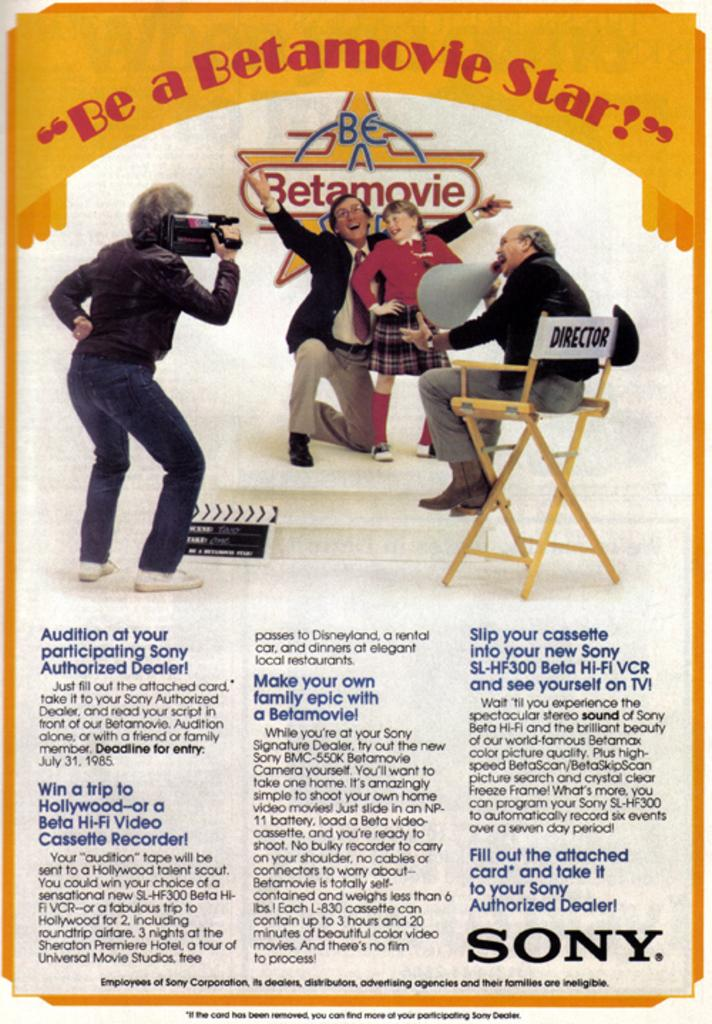What is the person carrying in the image? The person is carrying a camera in the image. What is the girl doing in the image? There is a girl standing in the image. What is the person sitting on a chair doing in the image? The person sitting on the chair is holding a speaker in their hand. What type of end can be seen in the image? There is no end present in the image. What type of songs can be heard coming from the speaker in the image? There is no indication in the image that any songs are being played from the speaker. What type of doll can be seen sitting on the chair in the image? There is no doll present in the image; it is a person sitting on the chair holding a speaker. 